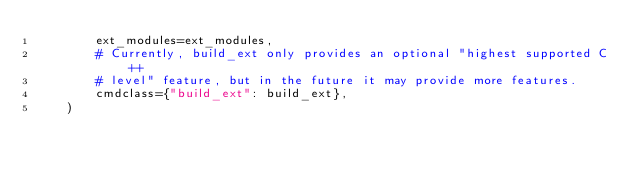Convert code to text. <code><loc_0><loc_0><loc_500><loc_500><_Python_>        ext_modules=ext_modules,
        # Currently, build_ext only provides an optional "highest supported C++
        # level" feature, but in the future it may provide more features.
        cmdclass={"build_ext": build_ext},
    )
</code> 